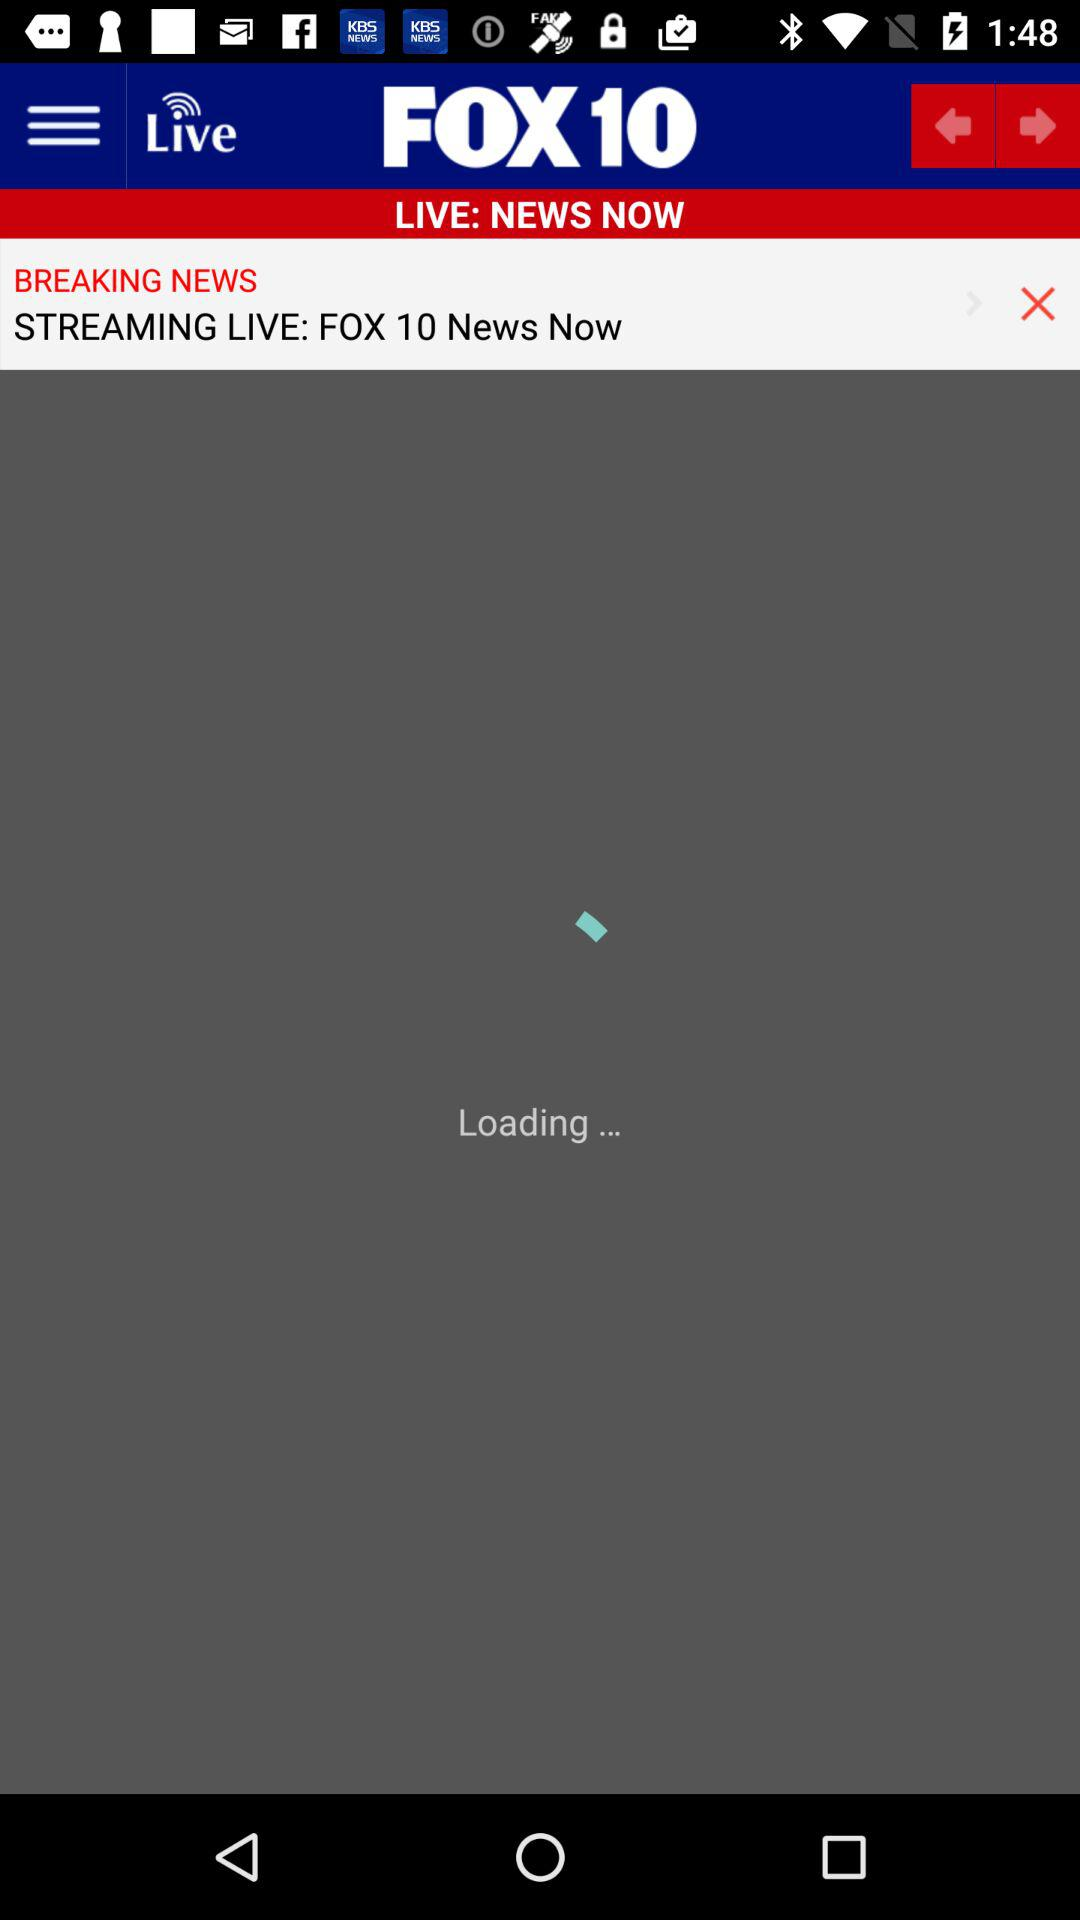What is streaming live?
When the provided information is insufficient, respond with <no answer>. <no answer> 